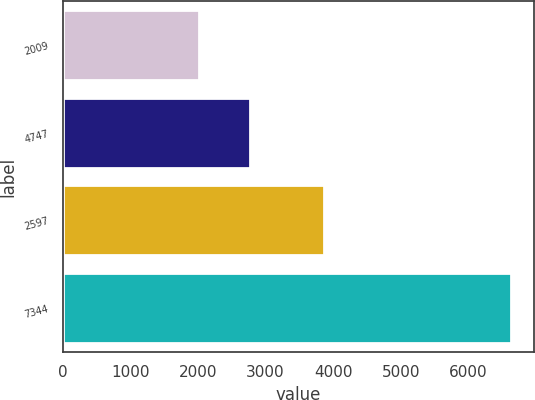Convert chart. <chart><loc_0><loc_0><loc_500><loc_500><bar_chart><fcel>2009<fcel>4747<fcel>2597<fcel>7344<nl><fcel>2009<fcel>2771<fcel>3863<fcel>6634<nl></chart> 